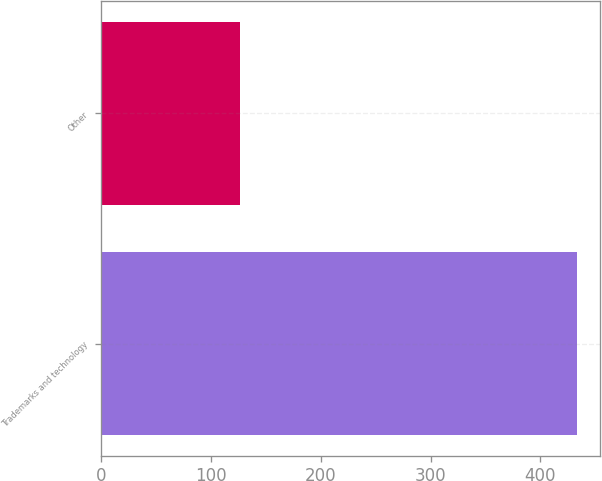Convert chart. <chart><loc_0><loc_0><loc_500><loc_500><bar_chart><fcel>Trademarks and technology<fcel>Other<nl><fcel>433<fcel>126<nl></chart> 